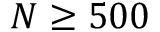Convert formula to latex. <formula><loc_0><loc_0><loc_500><loc_500>N \geq 5 0 0</formula> 